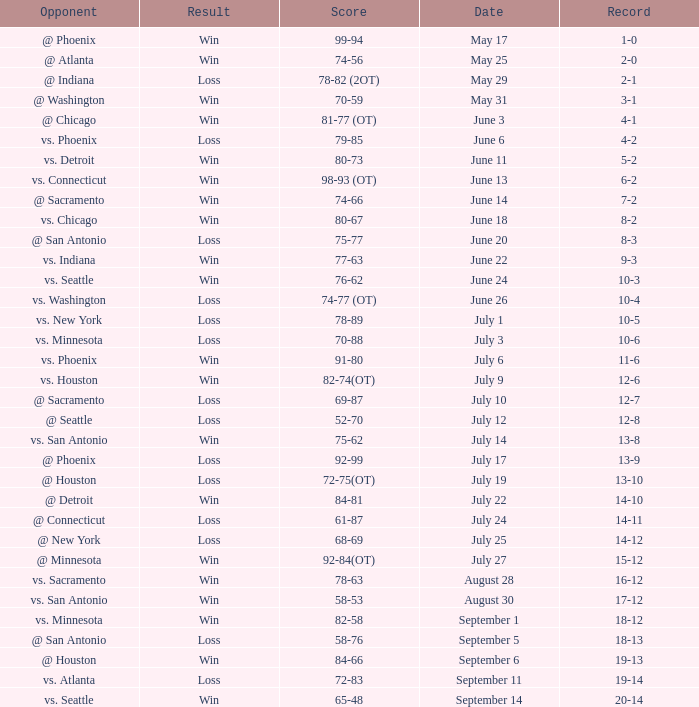Could you parse the entire table? {'header': ['Opponent', 'Result', 'Score', 'Date', 'Record'], 'rows': [['@ Phoenix', 'Win', '99-94', 'May 17', '1-0'], ['@ Atlanta', 'Win', '74-56', 'May 25', '2-0'], ['@ Indiana', 'Loss', '78-82 (2OT)', 'May 29', '2-1'], ['@ Washington', 'Win', '70-59', 'May 31', '3-1'], ['@ Chicago', 'Win', '81-77 (OT)', 'June 3', '4-1'], ['vs. Phoenix', 'Loss', '79-85', 'June 6', '4-2'], ['vs. Detroit', 'Win', '80-73', 'June 11', '5-2'], ['vs. Connecticut', 'Win', '98-93 (OT)', 'June 13', '6-2'], ['@ Sacramento', 'Win', '74-66', 'June 14', '7-2'], ['vs. Chicago', 'Win', '80-67', 'June 18', '8-2'], ['@ San Antonio', 'Loss', '75-77', 'June 20', '8-3'], ['vs. Indiana', 'Win', '77-63', 'June 22', '9-3'], ['vs. Seattle', 'Win', '76-62', 'June 24', '10-3'], ['vs. Washington', 'Loss', '74-77 (OT)', 'June 26', '10-4'], ['vs. New York', 'Loss', '78-89', 'July 1', '10-5'], ['vs. Minnesota', 'Loss', '70-88', 'July 3', '10-6'], ['vs. Phoenix', 'Win', '91-80', 'July 6', '11-6'], ['vs. Houston', 'Win', '82-74(OT)', 'July 9', '12-6'], ['@ Sacramento', 'Loss', '69-87', 'July 10', '12-7'], ['@ Seattle', 'Loss', '52-70', 'July 12', '12-8'], ['vs. San Antonio', 'Win', '75-62', 'July 14', '13-8'], ['@ Phoenix', 'Loss', '92-99', 'July 17', '13-9'], ['@ Houston', 'Loss', '72-75(OT)', 'July 19', '13-10'], ['@ Detroit', 'Win', '84-81', 'July 22', '14-10'], ['@ Connecticut', 'Loss', '61-87', 'July 24', '14-11'], ['@ New York', 'Loss', '68-69', 'July 25', '14-12'], ['@ Minnesota', 'Win', '92-84(OT)', 'July 27', '15-12'], ['vs. Sacramento', 'Win', '78-63', 'August 28', '16-12'], ['vs. San Antonio', 'Win', '58-53', 'August 30', '17-12'], ['vs. Minnesota', 'Win', '82-58', 'September 1', '18-12'], ['@ San Antonio', 'Loss', '58-76', 'September 5', '18-13'], ['@ Houston', 'Win', '84-66', 'September 6', '19-13'], ['vs. Atlanta', 'Loss', '72-83', 'September 11', '19-14'], ['vs. Seattle', 'Win', '65-48', 'September 14', '20-14']]} What is the Record of the game on September 6? 19-13. 